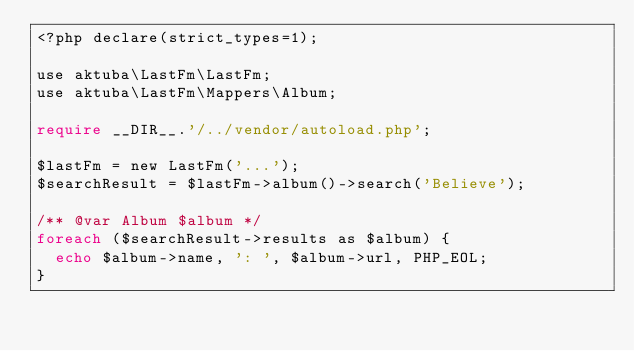Convert code to text. <code><loc_0><loc_0><loc_500><loc_500><_PHP_><?php declare(strict_types=1);

use aktuba\LastFm\LastFm;
use aktuba\LastFm\Mappers\Album;

require __DIR__.'/../vendor/autoload.php';

$lastFm = new LastFm('...');
$searchResult = $lastFm->album()->search('Believe');

/** @var Album $album */
foreach ($searchResult->results as $album) {
	echo $album->name, ': ', $album->url, PHP_EOL;
}
</code> 